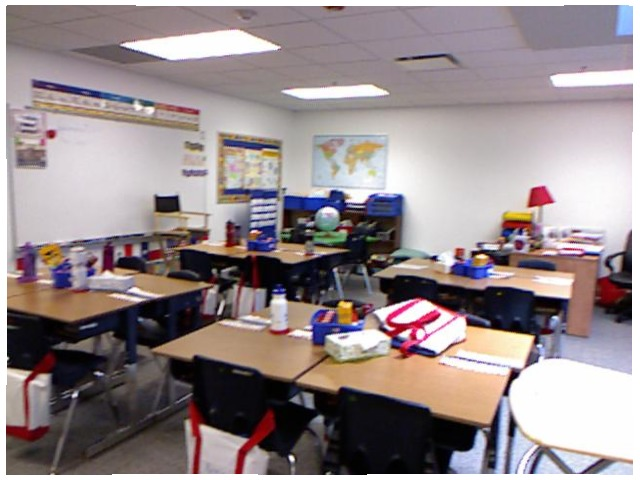<image>
Is there a map above the shelves? Yes. The map is positioned above the shelves in the vertical space, higher up in the scene. Is the picture on the wall? Yes. Looking at the image, I can see the picture is positioned on top of the wall, with the wall providing support. Is there a chair on the table? No. The chair is not positioned on the table. They may be near each other, but the chair is not supported by or resting on top of the table. Is the chair under the table? Yes. The chair is positioned underneath the table, with the table above it in the vertical space. 